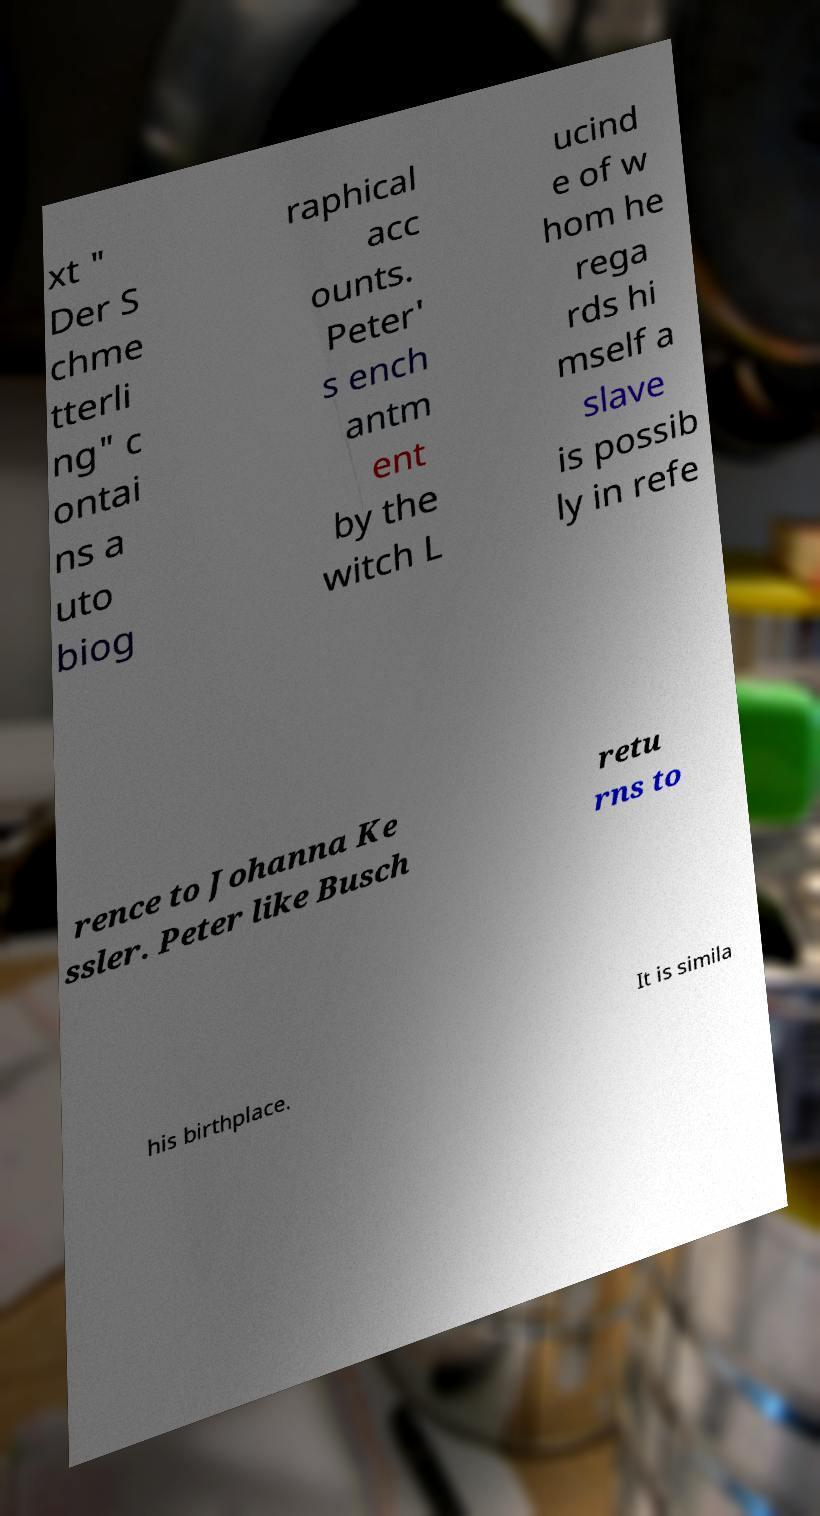Can you accurately transcribe the text from the provided image for me? xt " Der S chme tterli ng" c ontai ns a uto biog raphical acc ounts. Peter' s ench antm ent by the witch L ucind e of w hom he rega rds hi mself a slave is possib ly in refe rence to Johanna Ke ssler. Peter like Busch retu rns to his birthplace. It is simila 